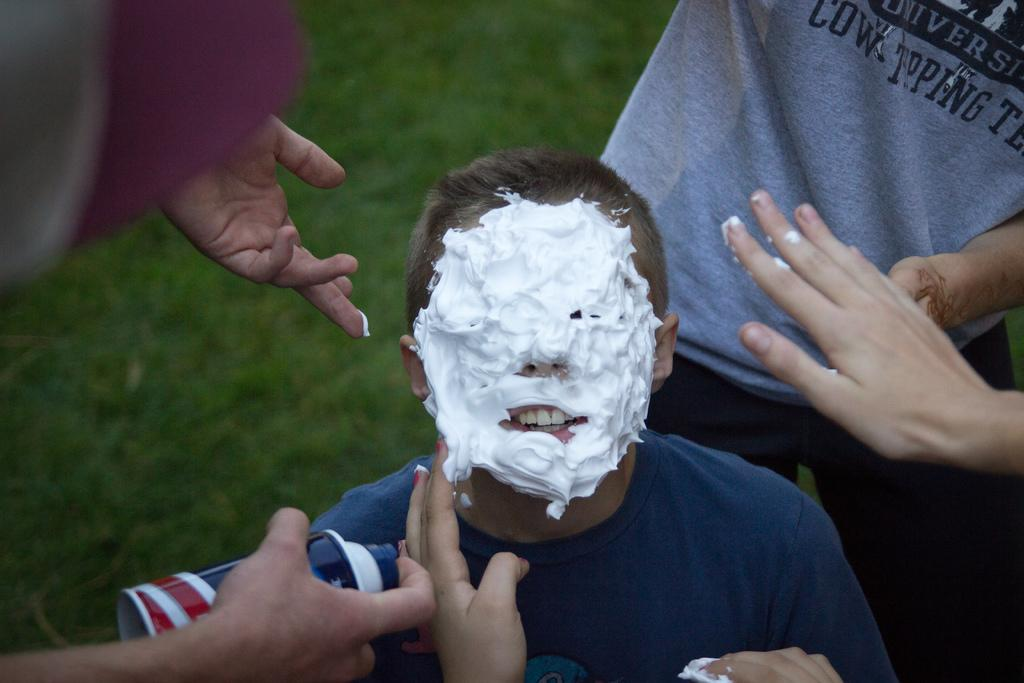How many people are in the image? There is a group of people in the image. What is one person holding in the image? One person is holding a spray bottle. What is happening to the person with cream on his face? There is a person with cream on his face, which suggests that he might have been involved in a prank or activity involving cream. What type of natural environment is visible in the image? There is grass visible in the image. What type of quicksand can be seen in the image? There is no quicksand present in the image. How many things are visible in the image? The question is unclear and cannot be definitively answered based on the provided facts. The image contains a group of people, a person holding a spray bottle, a person with cream on his face, and grass, but it is not clear what "things" refers to in this context. 